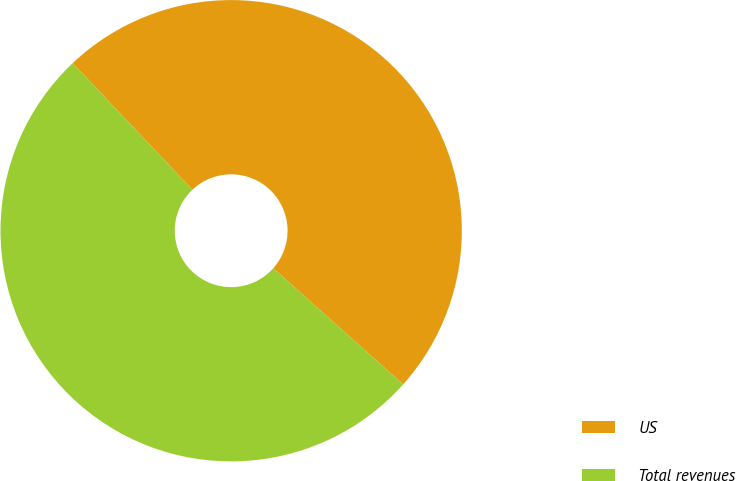Convert chart. <chart><loc_0><loc_0><loc_500><loc_500><pie_chart><fcel>US<fcel>Total revenues<nl><fcel>48.66%<fcel>51.34%<nl></chart> 